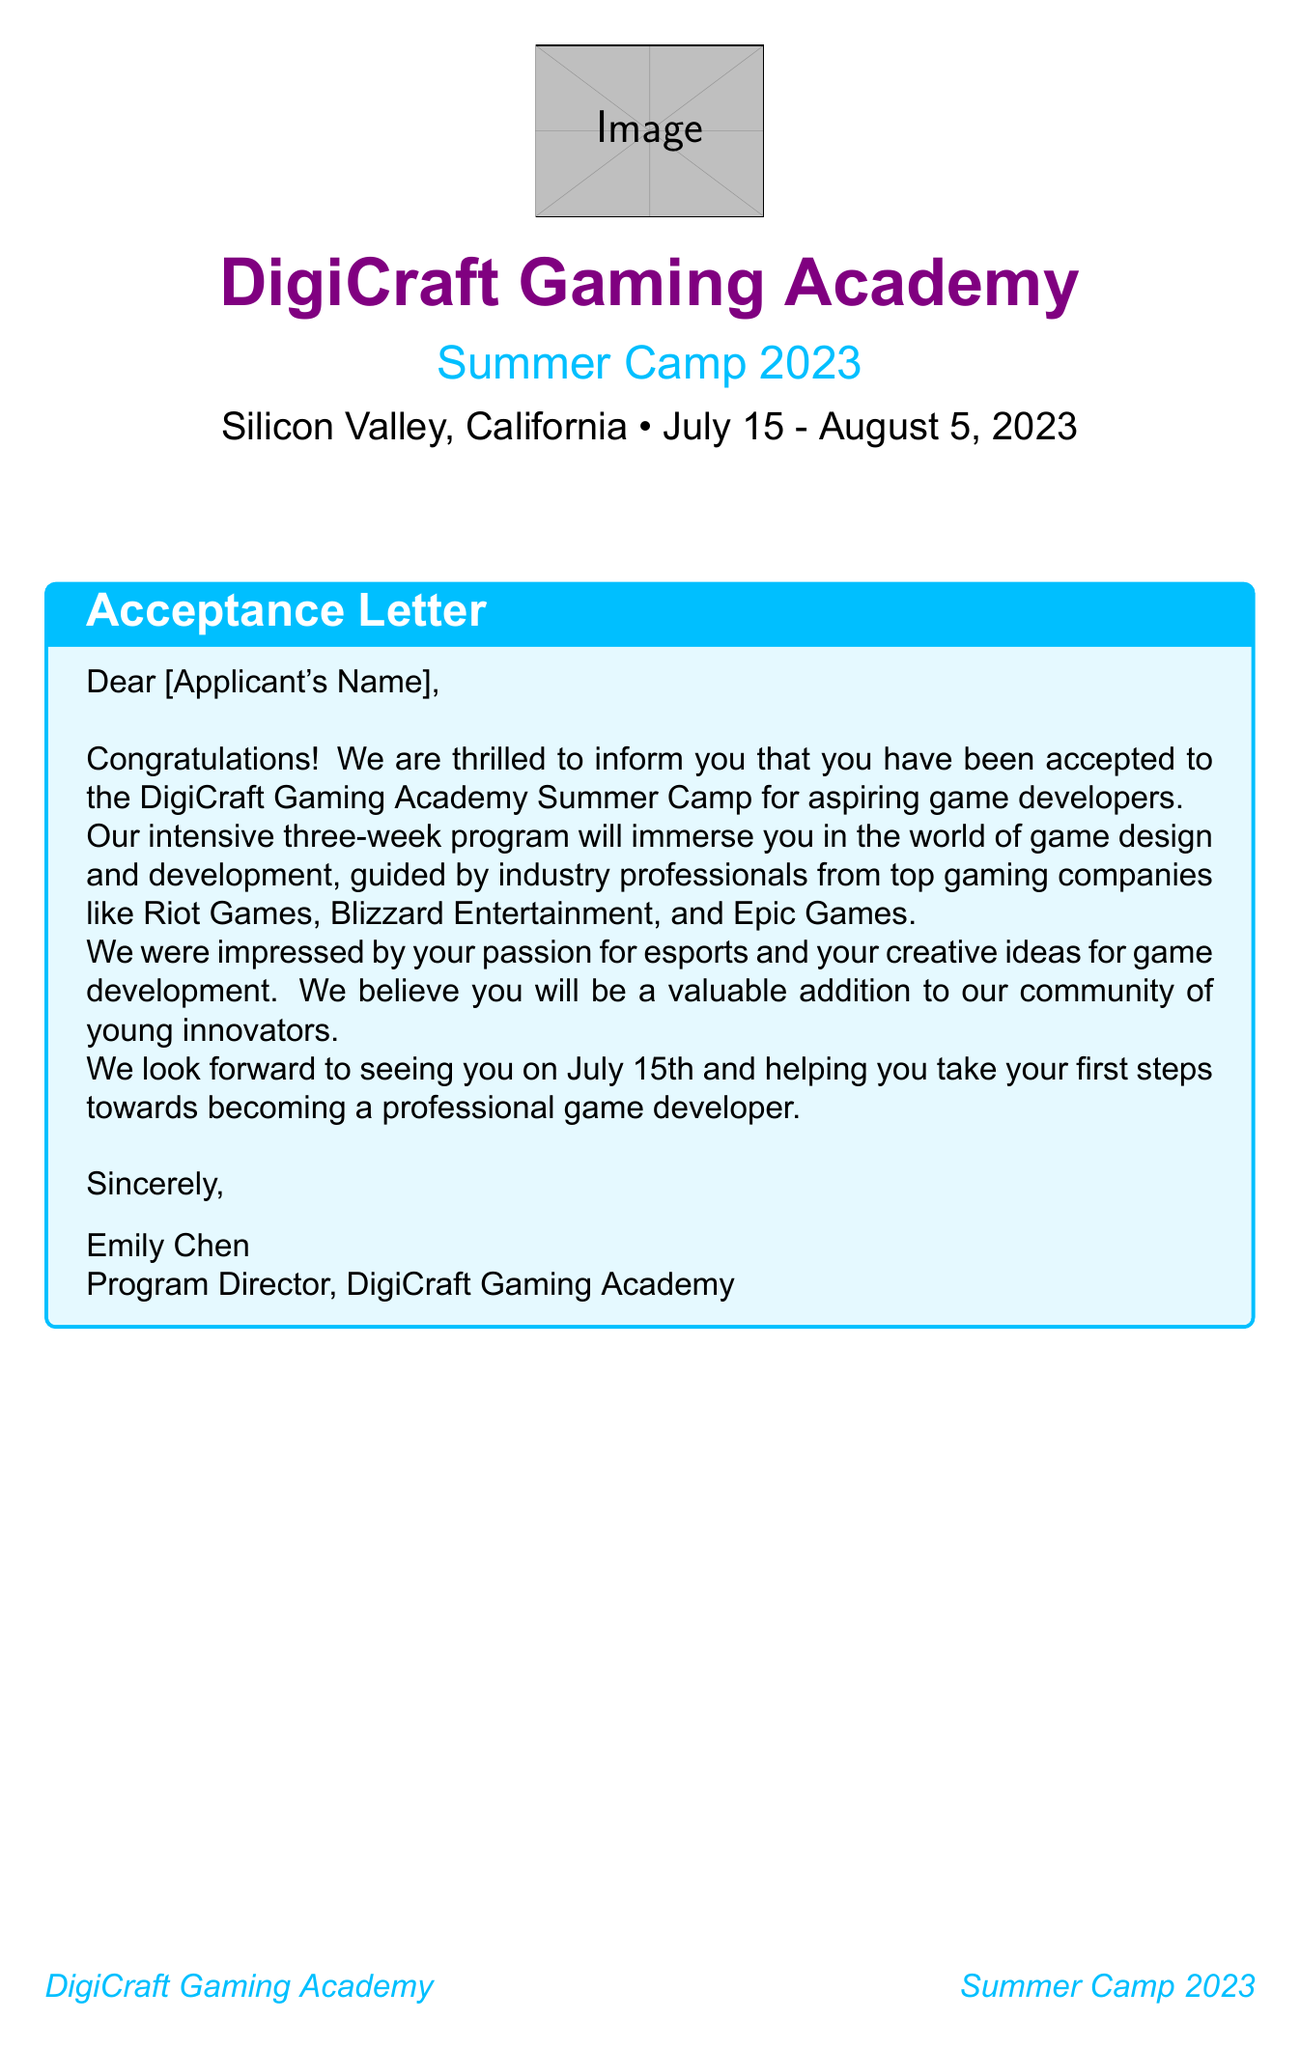What is the name of the camp? The camp is officially titled "DigiCraft Gaming Academy."
Answer: DigiCraft Gaming Academy Where will the camp be located? The camp location is specified in the document.
Answer: Silicon Valley, California What are the dates of the camp? The dates for attending the camp are given in the document.
Answer: July 15 - August 5, 2023 Who is the Program Director? The document mentions the name of the Program Director at the camp.
Answer: Emily Chen How many weeks does the program last? This information is found in the opening statement of the letter.
Answer: Three weeks What time does breakfast start on weekdays? The daily schedule outlines the time for breakfast on weekdays.
Answer: 7:30 AM What activity happens during the first week? The document lists a special event that occurs in the first week of the camp.
Answer: Virtual Reality Workshop with Oculus developers What item is optional but encouraged in the packing list? The packing list includes an item that is mentioned as optional but encouraged.
Answer: Gaming-themed t-shirts What is the emergency phone number provided? The document contains contact information that includes an emergency phone number.
Answer: +1 (650) 555-0123 